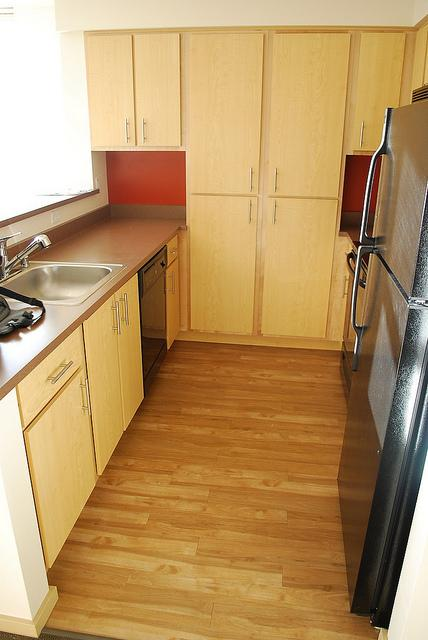What is going on with this room?

Choices:
A) dirty
B) being painted
C) being remodeled
D) no occupant no occupant 